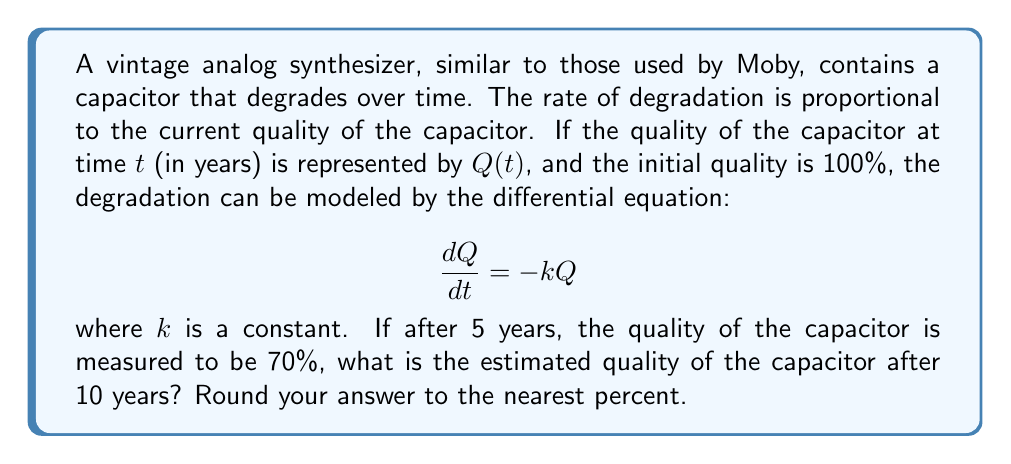Show me your answer to this math problem. To solve this problem, we'll follow these steps:

1) The given differential equation is a first-order linear differential equation. Its general solution is:

   $$Q(t) = Q_0e^{-kt}$$

   where $Q_0$ is the initial quality (100% or 1 in decimal form).

2) We need to find $k$ using the given information that after 5 years, the quality is 70%:

   $$0.7 = 1 \cdot e^{-5k}$$

3) Taking the natural logarithm of both sides:

   $$\ln(0.7) = -5k$$

4) Solving for $k$:

   $$k = -\frac{\ln(0.7)}{5} \approx 0.0713$$

5) Now that we have $k$, we can use the general solution to find the quality after 10 years:

   $$Q(10) = 1 \cdot e^{-0.0713 \cdot 10}$$

6) Calculating this:

   $$Q(10) \approx 0.4909$$

7) Converting to a percentage:

   $$0.4909 \cdot 100\% \approx 49.09\%$$

8) Rounding to the nearest percent:

   $$49\%$$
Answer: 49% 